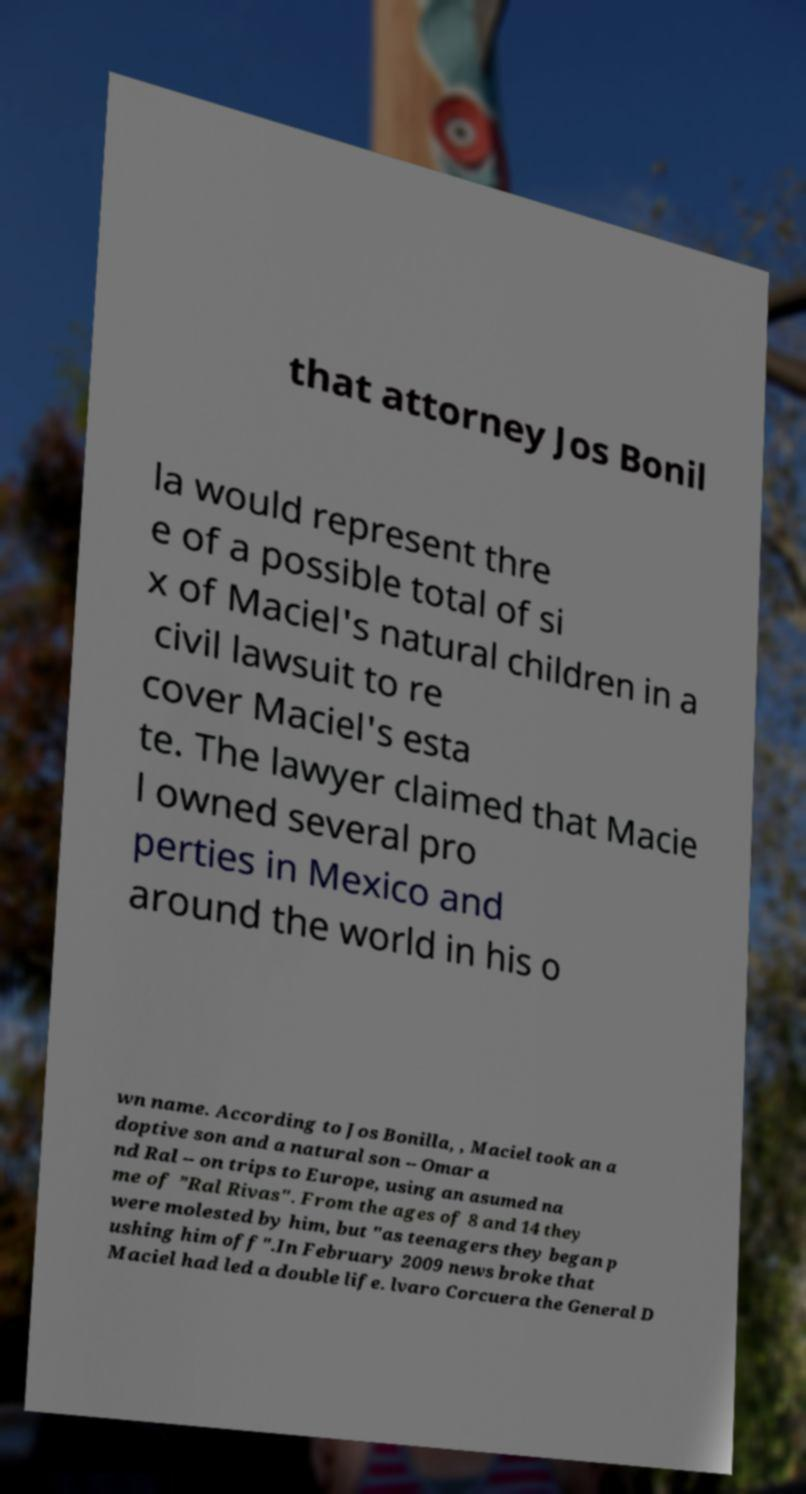Can you read and provide the text displayed in the image?This photo seems to have some interesting text. Can you extract and type it out for me? that attorney Jos Bonil la would represent thre e of a possible total of si x of Maciel's natural children in a civil lawsuit to re cover Maciel's esta te. The lawyer claimed that Macie l owned several pro perties in Mexico and around the world in his o wn name. According to Jos Bonilla, , Maciel took an a doptive son and a natural son -- Omar a nd Ral -- on trips to Europe, using an asumed na me of ”Ral Rivas". From the ages of 8 and 14 they were molested by him, but "as teenagers they began p ushing him off".In February 2009 news broke that Maciel had led a double life. lvaro Corcuera the General D 